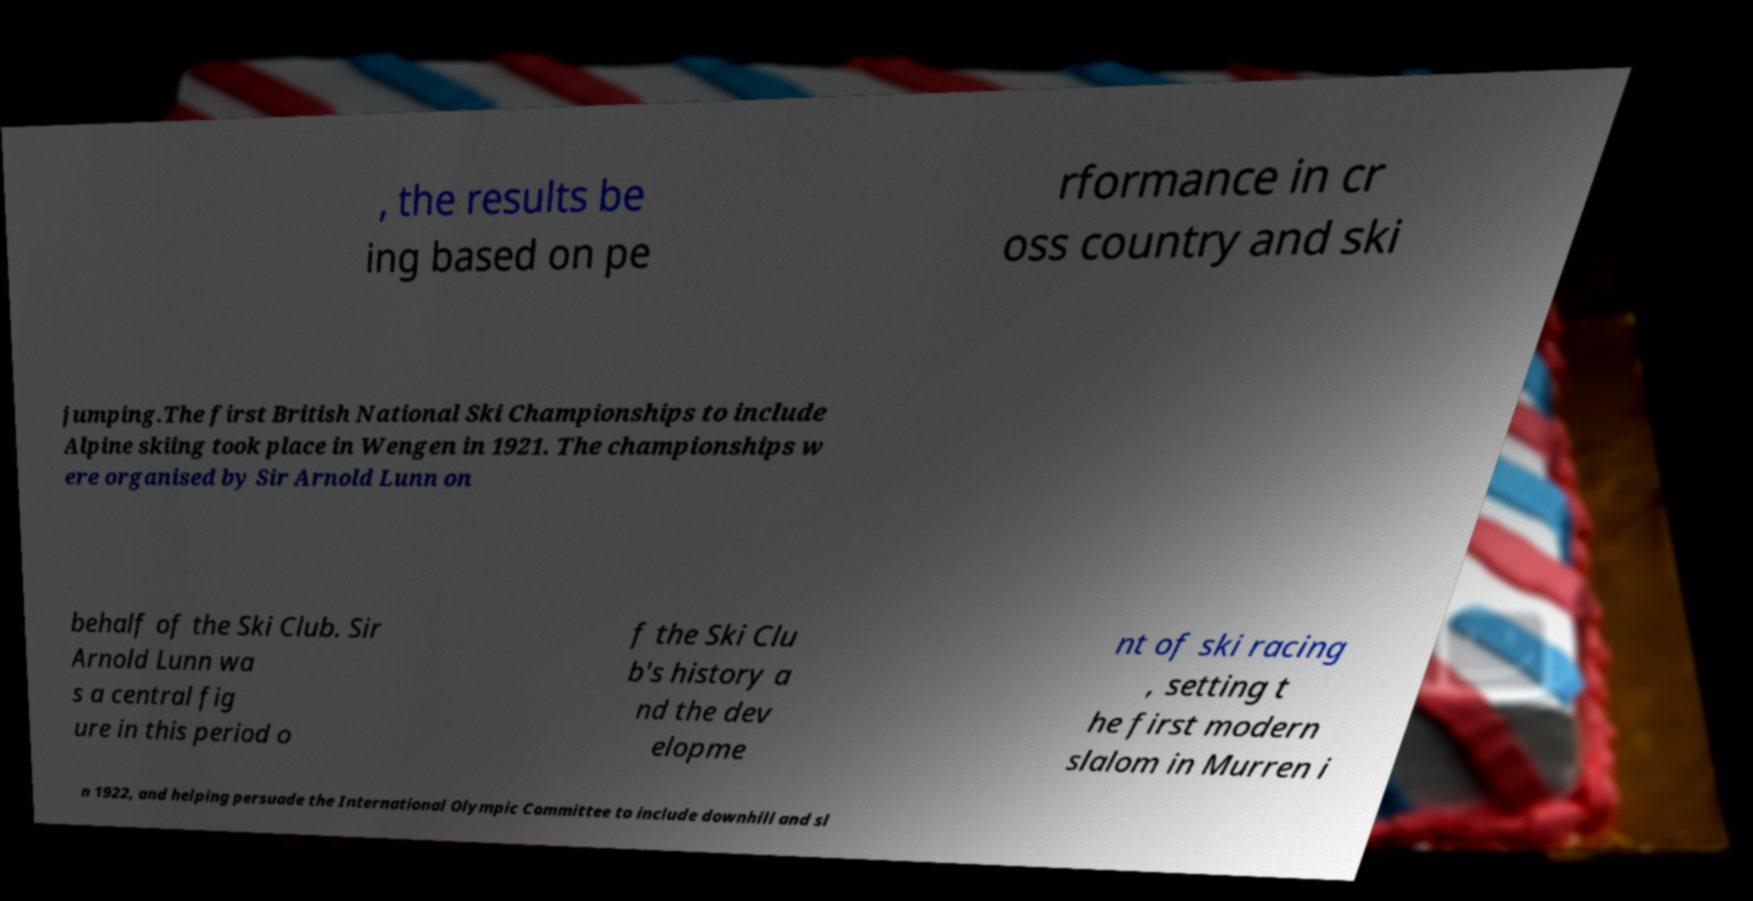Can you accurately transcribe the text from the provided image for me? , the results be ing based on pe rformance in cr oss country and ski jumping.The first British National Ski Championships to include Alpine skiing took place in Wengen in 1921. The championships w ere organised by Sir Arnold Lunn on behalf of the Ski Club. Sir Arnold Lunn wa s a central fig ure in this period o f the Ski Clu b's history a nd the dev elopme nt of ski racing , setting t he first modern slalom in Murren i n 1922, and helping persuade the International Olympic Committee to include downhill and sl 